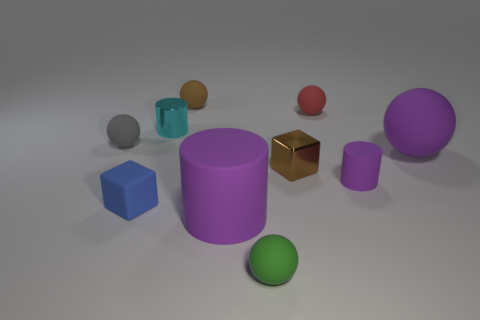Subtract all green spheres. How many spheres are left? 4 Subtract all purple cubes. How many purple cylinders are left? 2 Subtract 2 blocks. How many blocks are left? 0 Subtract all blue cubes. How many cubes are left? 1 Subtract all cylinders. How many objects are left? 7 Add 5 small brown things. How many small brown things exist? 7 Subtract 0 green cylinders. How many objects are left? 10 Subtract all brown balls. Subtract all yellow blocks. How many balls are left? 4 Subtract all small blue rubber cylinders. Subtract all tiny gray objects. How many objects are left? 9 Add 8 tiny green spheres. How many tiny green spheres are left? 9 